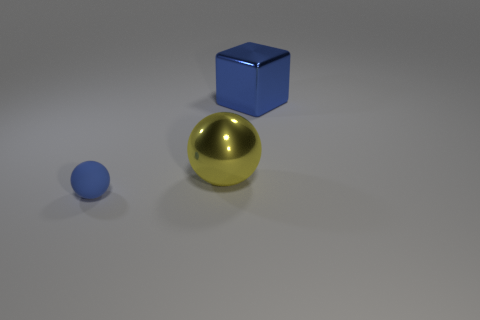Does the blue object that is in front of the big blue shiny block have the same material as the thing that is right of the yellow ball?
Your response must be concise. No. Is there anything else that is the same shape as the big blue object?
Your answer should be compact. No. Is the material of the large blue block the same as the big thing in front of the block?
Give a very brief answer. Yes. The ball that is behind the sphere left of the ball that is to the right of the small matte thing is what color?
Ensure brevity in your answer.  Yellow. What is the shape of the yellow thing that is the same size as the cube?
Your response must be concise. Sphere. Are there any other things that are the same size as the blue rubber object?
Provide a succinct answer. No. Do the blue object left of the big metal cube and the metallic thing that is left of the blue shiny cube have the same size?
Provide a short and direct response. No. What is the size of the sphere left of the large metal ball?
Offer a terse response. Small. There is a sphere that is the same color as the shiny cube; what is it made of?
Give a very brief answer. Rubber. There is another object that is the same size as the yellow object; what color is it?
Your answer should be compact. Blue. 